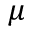Convert formula to latex. <formula><loc_0><loc_0><loc_500><loc_500>\mu</formula> 